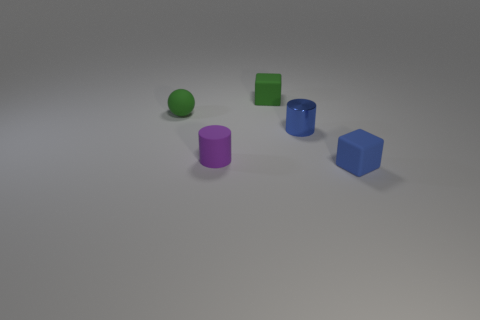What shape is the green thing that is made of the same material as the small green ball?
Make the answer very short. Cube. Are any small matte cubes visible?
Give a very brief answer. Yes. Is the number of green things to the right of the small green matte cube less than the number of green balls in front of the tiny blue cylinder?
Provide a succinct answer. No. What is the shape of the green rubber object that is behind the tiny green ball?
Ensure brevity in your answer.  Cube. Does the blue cylinder have the same material as the green sphere?
Offer a very short reply. No. Is there any other thing that is made of the same material as the sphere?
Ensure brevity in your answer.  Yes. There is another object that is the same shape as the tiny metal thing; what material is it?
Ensure brevity in your answer.  Rubber. Is the number of tiny spheres that are on the right side of the blue metallic object less than the number of tiny matte things?
Give a very brief answer. Yes. There is a blue cube; how many small blue things are behind it?
Offer a very short reply. 1. There is a blue object that is right of the blue metal cylinder; is it the same shape as the tiny green object that is in front of the green rubber block?
Give a very brief answer. No. 